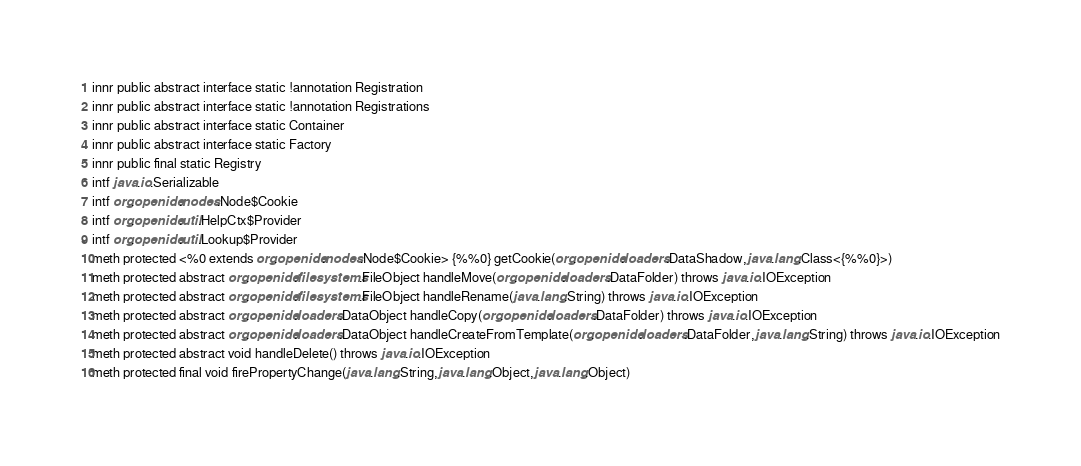<code> <loc_0><loc_0><loc_500><loc_500><_SML_>innr public abstract interface static !annotation Registration
innr public abstract interface static !annotation Registrations
innr public abstract interface static Container
innr public abstract interface static Factory
innr public final static Registry
intf java.io.Serializable
intf org.openide.nodes.Node$Cookie
intf org.openide.util.HelpCtx$Provider
intf org.openide.util.Lookup$Provider
meth protected <%0 extends org.openide.nodes.Node$Cookie> {%%0} getCookie(org.openide.loaders.DataShadow,java.lang.Class<{%%0}>)
meth protected abstract org.openide.filesystems.FileObject handleMove(org.openide.loaders.DataFolder) throws java.io.IOException
meth protected abstract org.openide.filesystems.FileObject handleRename(java.lang.String) throws java.io.IOException
meth protected abstract org.openide.loaders.DataObject handleCopy(org.openide.loaders.DataFolder) throws java.io.IOException
meth protected abstract org.openide.loaders.DataObject handleCreateFromTemplate(org.openide.loaders.DataFolder,java.lang.String) throws java.io.IOException
meth protected abstract void handleDelete() throws java.io.IOException
meth protected final void firePropertyChange(java.lang.String,java.lang.Object,java.lang.Object)</code> 